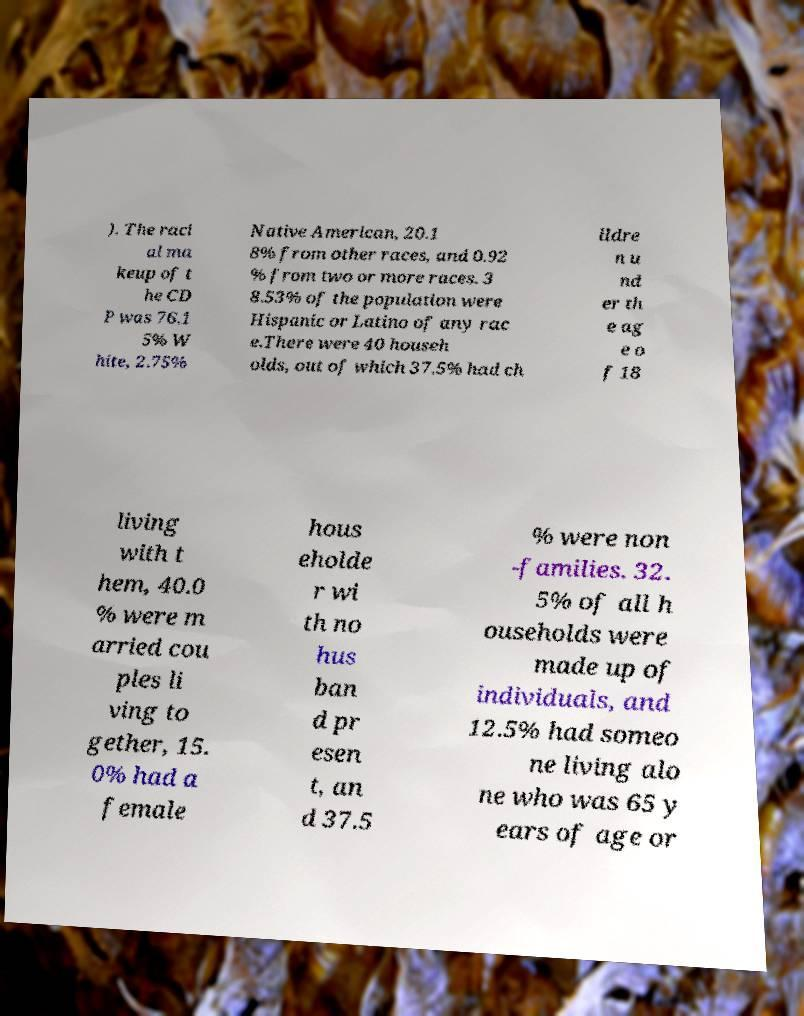Could you extract and type out the text from this image? ). The raci al ma keup of t he CD P was 76.1 5% W hite, 2.75% Native American, 20.1 8% from other races, and 0.92 % from two or more races. 3 8.53% of the population were Hispanic or Latino of any rac e.There were 40 househ olds, out of which 37.5% had ch ildre n u nd er th e ag e o f 18 living with t hem, 40.0 % were m arried cou ples li ving to gether, 15. 0% had a female hous eholde r wi th no hus ban d pr esen t, an d 37.5 % were non -families. 32. 5% of all h ouseholds were made up of individuals, and 12.5% had someo ne living alo ne who was 65 y ears of age or 